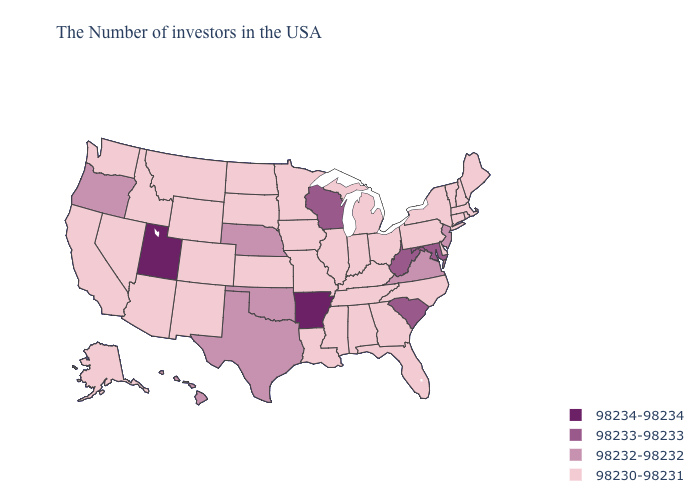Name the states that have a value in the range 98232-98232?
Be succinct. New Jersey, Virginia, Nebraska, Oklahoma, Texas, Oregon, Hawaii. Which states have the lowest value in the USA?
Concise answer only. Maine, Massachusetts, Rhode Island, New Hampshire, Vermont, Connecticut, New York, Delaware, Pennsylvania, North Carolina, Ohio, Florida, Georgia, Michigan, Kentucky, Indiana, Alabama, Tennessee, Illinois, Mississippi, Louisiana, Missouri, Minnesota, Iowa, Kansas, South Dakota, North Dakota, Wyoming, Colorado, New Mexico, Montana, Arizona, Idaho, Nevada, California, Washington, Alaska. Does the map have missing data?
Quick response, please. No. Name the states that have a value in the range 98230-98231?
Write a very short answer. Maine, Massachusetts, Rhode Island, New Hampshire, Vermont, Connecticut, New York, Delaware, Pennsylvania, North Carolina, Ohio, Florida, Georgia, Michigan, Kentucky, Indiana, Alabama, Tennessee, Illinois, Mississippi, Louisiana, Missouri, Minnesota, Iowa, Kansas, South Dakota, North Dakota, Wyoming, Colorado, New Mexico, Montana, Arizona, Idaho, Nevada, California, Washington, Alaska. Name the states that have a value in the range 98233-98233?
Concise answer only. Maryland, South Carolina, West Virginia, Wisconsin. Which states have the lowest value in the MidWest?
Be succinct. Ohio, Michigan, Indiana, Illinois, Missouri, Minnesota, Iowa, Kansas, South Dakota, North Dakota. Does the map have missing data?
Quick response, please. No. Which states have the lowest value in the USA?
Quick response, please. Maine, Massachusetts, Rhode Island, New Hampshire, Vermont, Connecticut, New York, Delaware, Pennsylvania, North Carolina, Ohio, Florida, Georgia, Michigan, Kentucky, Indiana, Alabama, Tennessee, Illinois, Mississippi, Louisiana, Missouri, Minnesota, Iowa, Kansas, South Dakota, North Dakota, Wyoming, Colorado, New Mexico, Montana, Arizona, Idaho, Nevada, California, Washington, Alaska. What is the value of Idaho?
Be succinct. 98230-98231. Name the states that have a value in the range 98232-98232?
Short answer required. New Jersey, Virginia, Nebraska, Oklahoma, Texas, Oregon, Hawaii. Name the states that have a value in the range 98232-98232?
Give a very brief answer. New Jersey, Virginia, Nebraska, Oklahoma, Texas, Oregon, Hawaii. What is the value of New Hampshire?
Quick response, please. 98230-98231. What is the value of Tennessee?
Short answer required. 98230-98231. What is the value of Wisconsin?
Write a very short answer. 98233-98233. Does Maryland have the lowest value in the USA?
Answer briefly. No. 